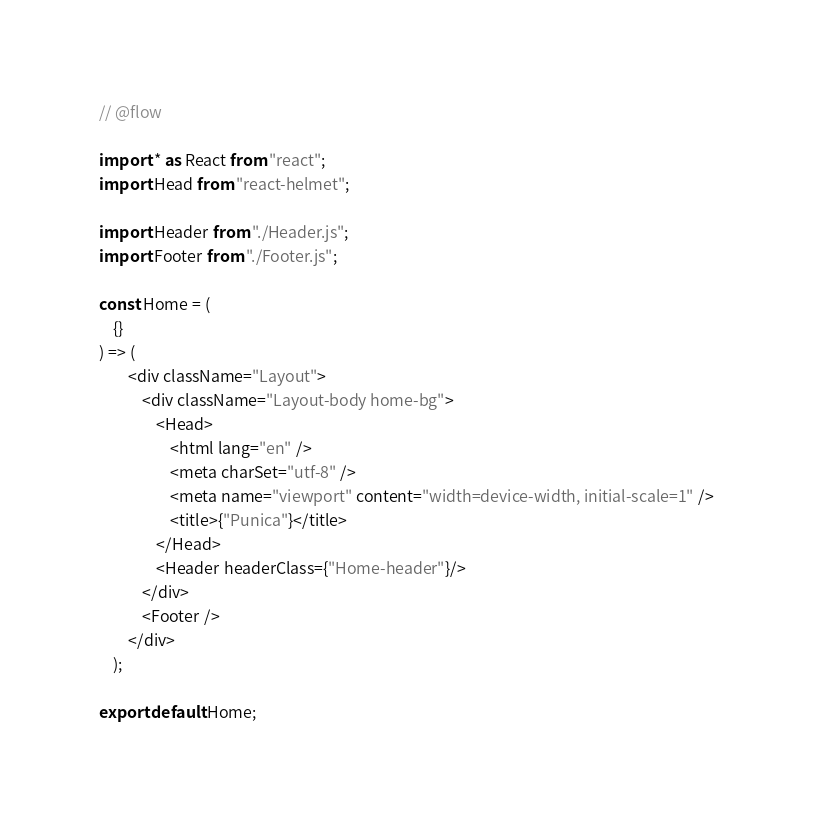<code> <loc_0><loc_0><loc_500><loc_500><_JavaScript_>// @flow

import * as React from "react";
import Head from "react-helmet";

import Header from "./Header.js";
import Footer from "./Footer.js";

const Home = (
    {} 
) => (
        <div className="Layout">
            <div className="Layout-body home-bg">
                <Head>
                    <html lang="en" />
                    <meta charSet="utf-8" />
                    <meta name="viewport" content="width=device-width, initial-scale=1" />
                    <title>{"Punica"}</title>
                </Head>
                <Header headerClass={"Home-header"}/>
            </div>
            <Footer />
        </div>
    );

export default Home;
</code> 